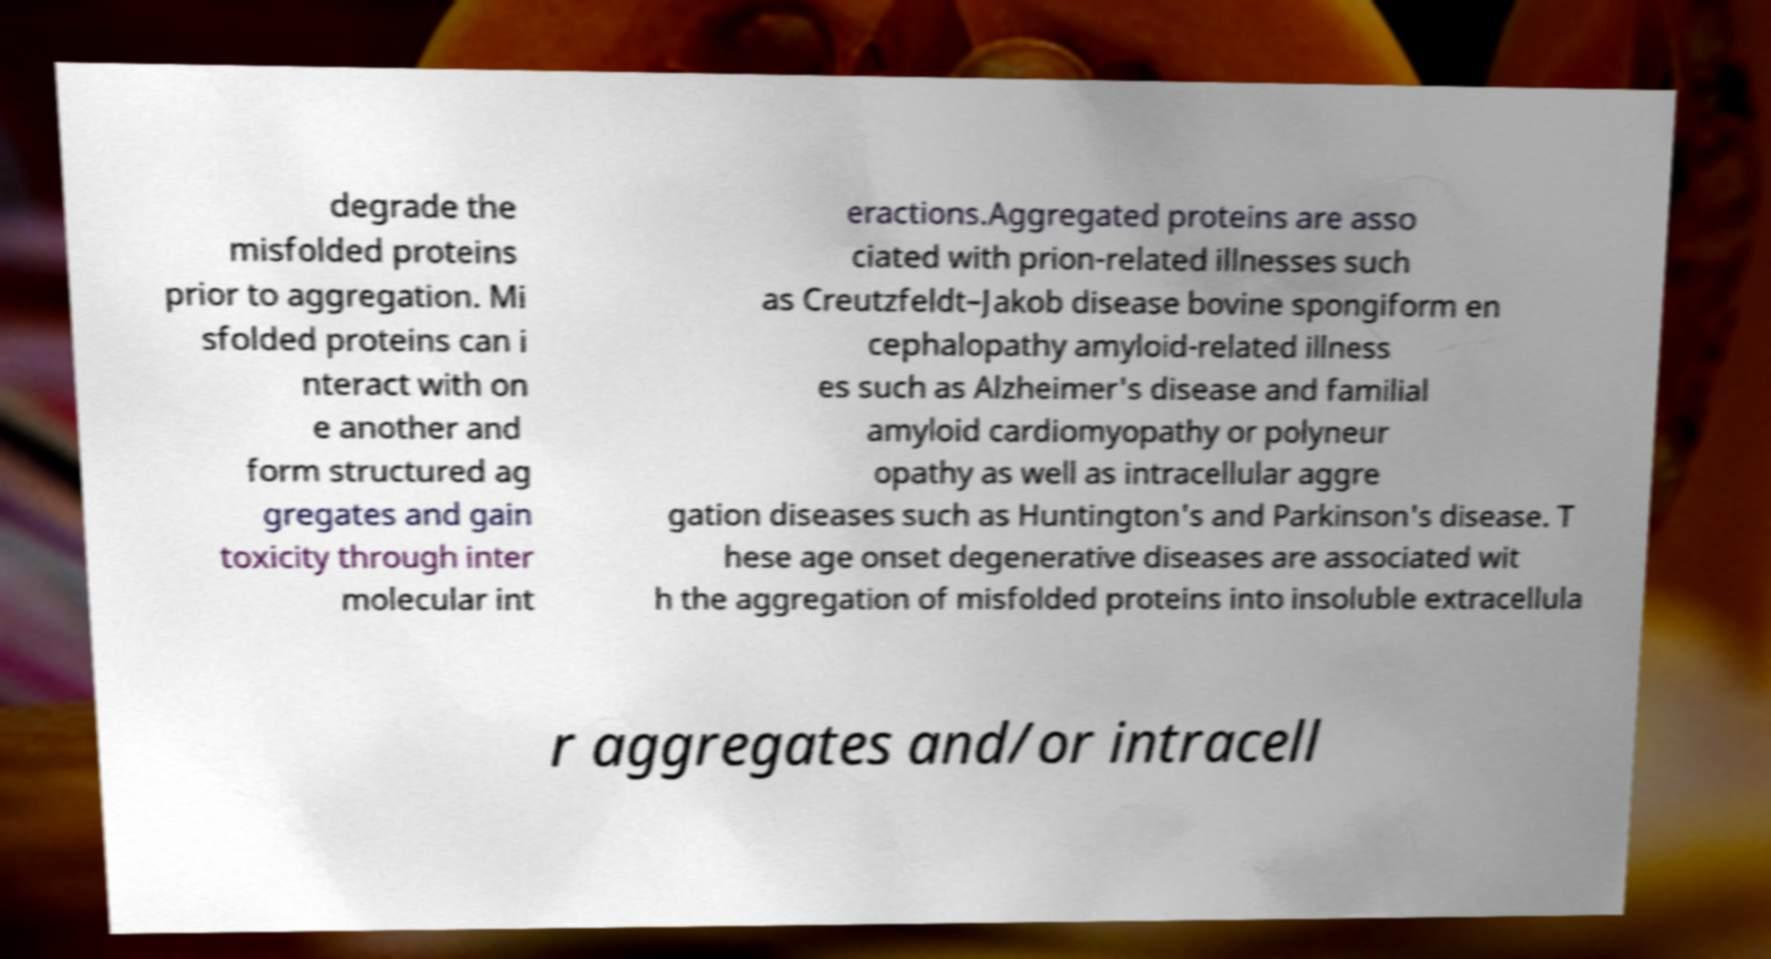For documentation purposes, I need the text within this image transcribed. Could you provide that? degrade the misfolded proteins prior to aggregation. Mi sfolded proteins can i nteract with on e another and form structured ag gregates and gain toxicity through inter molecular int eractions.Aggregated proteins are asso ciated with prion-related illnesses such as Creutzfeldt–Jakob disease bovine spongiform en cephalopathy amyloid-related illness es such as Alzheimer's disease and familial amyloid cardiomyopathy or polyneur opathy as well as intracellular aggre gation diseases such as Huntington's and Parkinson's disease. T hese age onset degenerative diseases are associated wit h the aggregation of misfolded proteins into insoluble extracellula r aggregates and/or intracell 